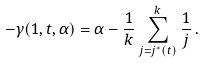Convert formula to latex. <formula><loc_0><loc_0><loc_500><loc_500>- \gamma ( 1 , t , \alpha ) = \alpha - \frac { 1 } { k } \sum _ { j = j ^ { * } ( t ) } ^ { k } \frac { 1 } { j } \, .</formula> 